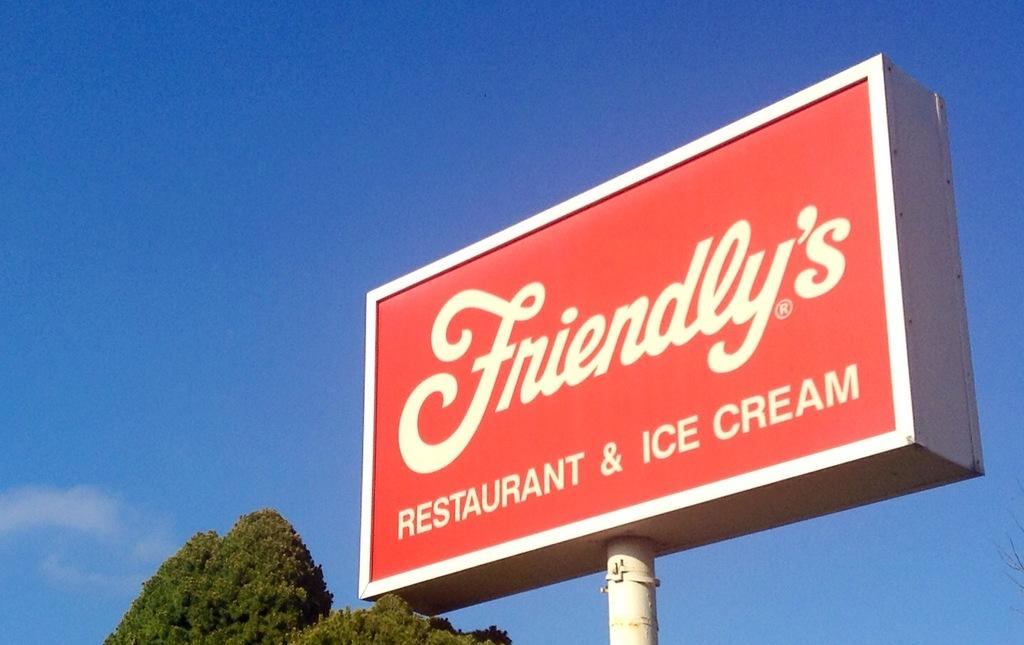<image>
Present a compact description of the photo's key features. A red sign reads "Friendly's Restaurat & Ice Cream." 